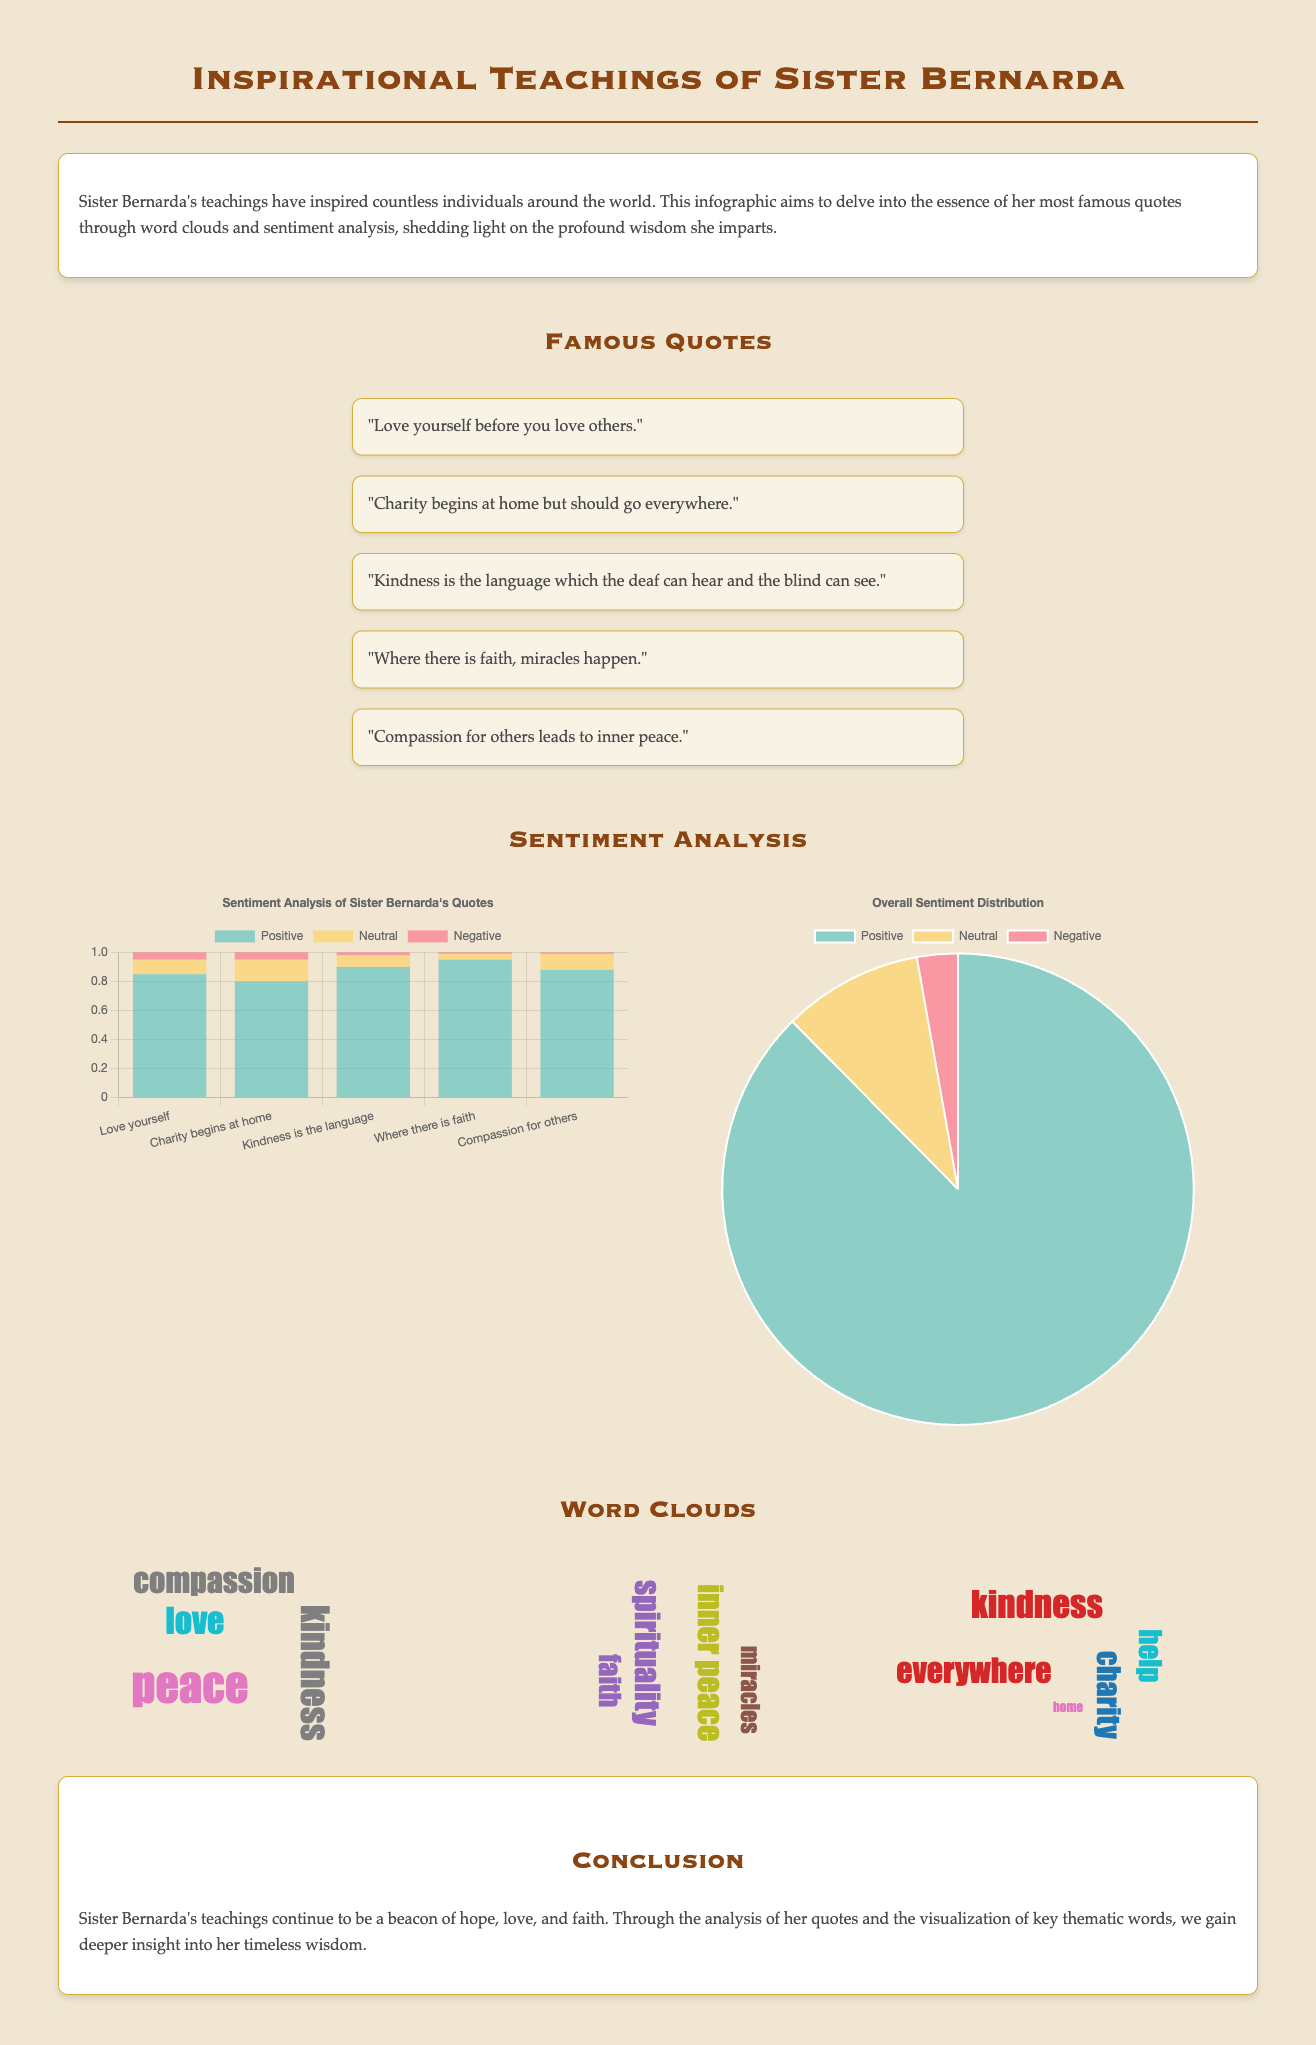What is the title of the infographic? The title of the infographic is stated prominently at the top of the document, emphasizing the theme of Sister Bernarda's teachings.
Answer: Inspirational Teachings of Sister Bernarda How many famous quotes are listed in the document? The document highlights a specific section titled "Famous Quotes," where five quotes from Sister Bernarda are displayed.
Answer: 5 What is the highest positive sentiment value in the sentiment analysis chart? The highest positive sentiment value is indicated in the bar chart, revealing the impact of one of Sister Bernarda's quotes.
Answer: 0.95 Which quote corresponds to the theme of love? The quote that best embodies the theme of love addresses the importance of self-love before loving others.
Answer: "Love yourself before you love others." What are the main themes represented in the word clouds? The three word clouds represent distinct themes based on key concepts found in Sister Bernarda's quotes, showcasing a broader understanding of her teachings.
Answer: Love, Faith, Charity How is the overall sentiment distribution categorized? The overall sentiment distribution is presented as a pie chart, categorizing sentiment into positive, neutral, and negative segments.
Answer: Positive, Neutral, Negative What color represents negative sentiment in the sentiment analysis chart? The color associated with negative sentiment in the sentiment analysis chart is highlighted to indicate its portion of the total.
Answer: Red What is the purpose of the infographic? The introduction section of the document outlines the goal of exploring Sister Bernarda's quotes through specific analytical methods.
Answer: Delve into her most famous quotes What design element enhances the visual appeal of the quotes section? The quotes section employs a fragmented layout, allowing each quote to stand out individually, enhancing overall engagement with the content.
Answer: Flex-wrap layout 